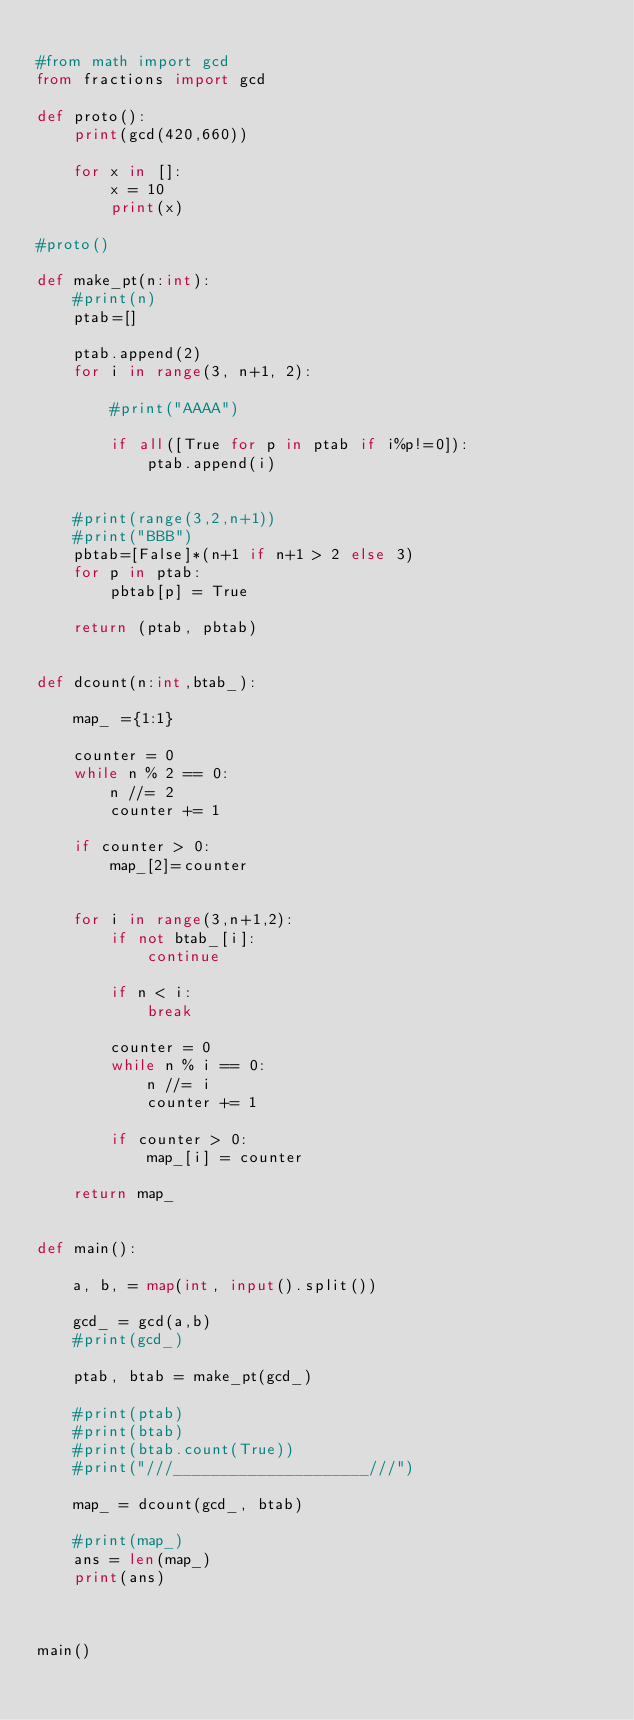Convert code to text. <code><loc_0><loc_0><loc_500><loc_500><_Python_>
#from math import gcd
from fractions import gcd

def proto():
    print(gcd(420,660))

    for x in []:
        x = 10
        print(x)

#proto()

def make_pt(n:int):
    #print(n)
    ptab=[]

    ptab.append(2)
    for i in range(3, n+1, 2):

        #print("AAAA")

        if all([True for p in ptab if i%p!=0]):
            ptab.append(i)


    #print(range(3,2,n+1))
    #print("BBB")
    pbtab=[False]*(n+1 if n+1 > 2 else 3)
    for p in ptab:
        pbtab[p] = True

    return (ptab, pbtab)
    

def dcount(n:int,btab_):

    map_ ={1:1}

    counter = 0
    while n % 2 == 0:
        n //= 2
        counter += 1

    if counter > 0:
        map_[2]=counter


    for i in range(3,n+1,2):
        if not btab_[i]:
            continue

        if n < i:
            break

        counter = 0
        while n % i == 0:
            n //= i
            counter += 1

        if counter > 0:
            map_[i] = counter

    return map_


def main():

    a, b, = map(int, input().split())

    gcd_ = gcd(a,b)
    #print(gcd_)

    ptab, btab = make_pt(gcd_)

    #print(ptab)
    #print(btab)
    #print(btab.count(True))
    #print("///_____________________///")

    map_ = dcount(gcd_, btab)

    #print(map_)
    ans = len(map_)
    print(ans)



main()</code> 